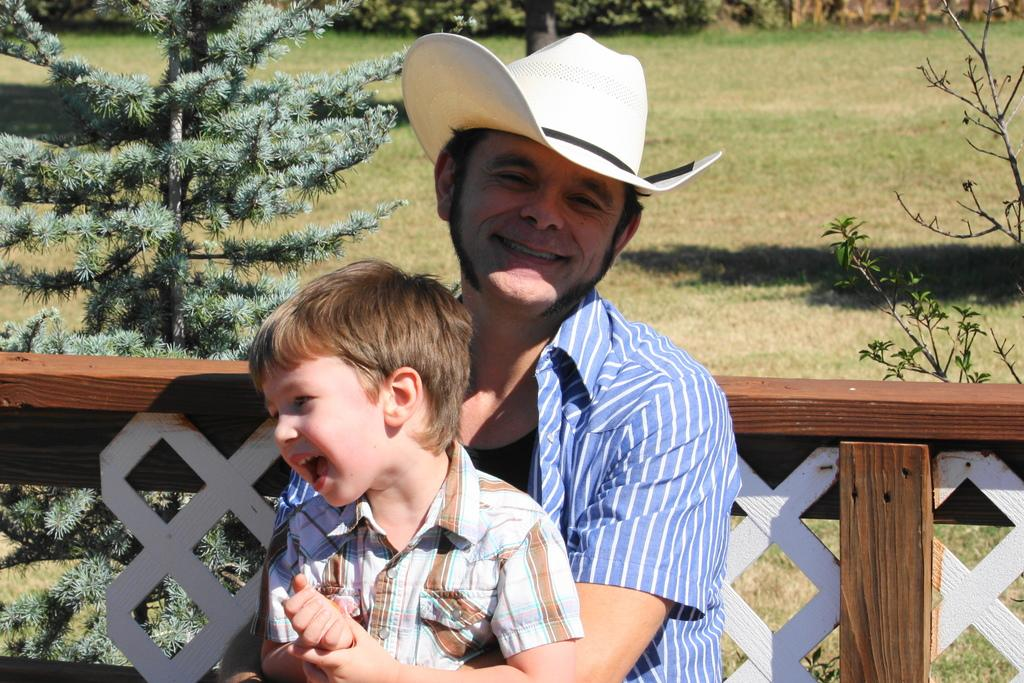Who is in the center of the image? There is a man and a kid in the center of the image. What can be seen in the background of the image? There are trees, fencing, and grass in the background of the image. What type of soup is being served in the image? There is no soup present in the image. What kind of trouble is the man causing in the image? There is no indication of trouble or any negative actions in the image. 